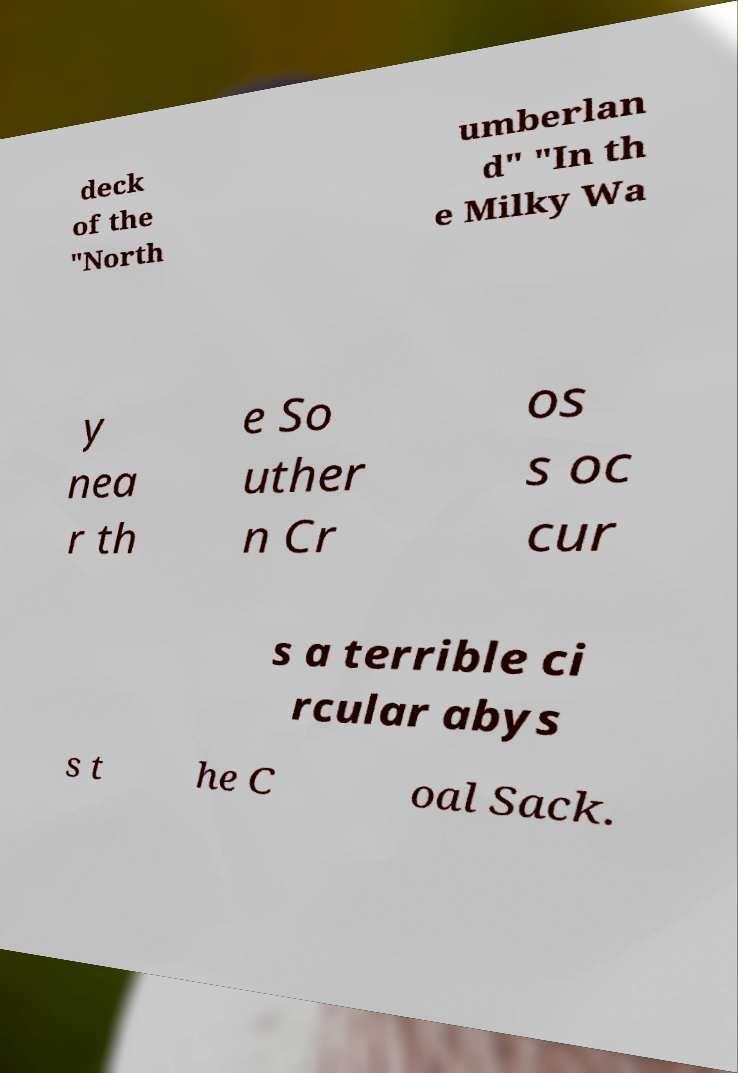Can you accurately transcribe the text from the provided image for me? deck of the "North umberlan d" "In th e Milky Wa y nea r th e So uther n Cr os s oc cur s a terrible ci rcular abys s t he C oal Sack. 